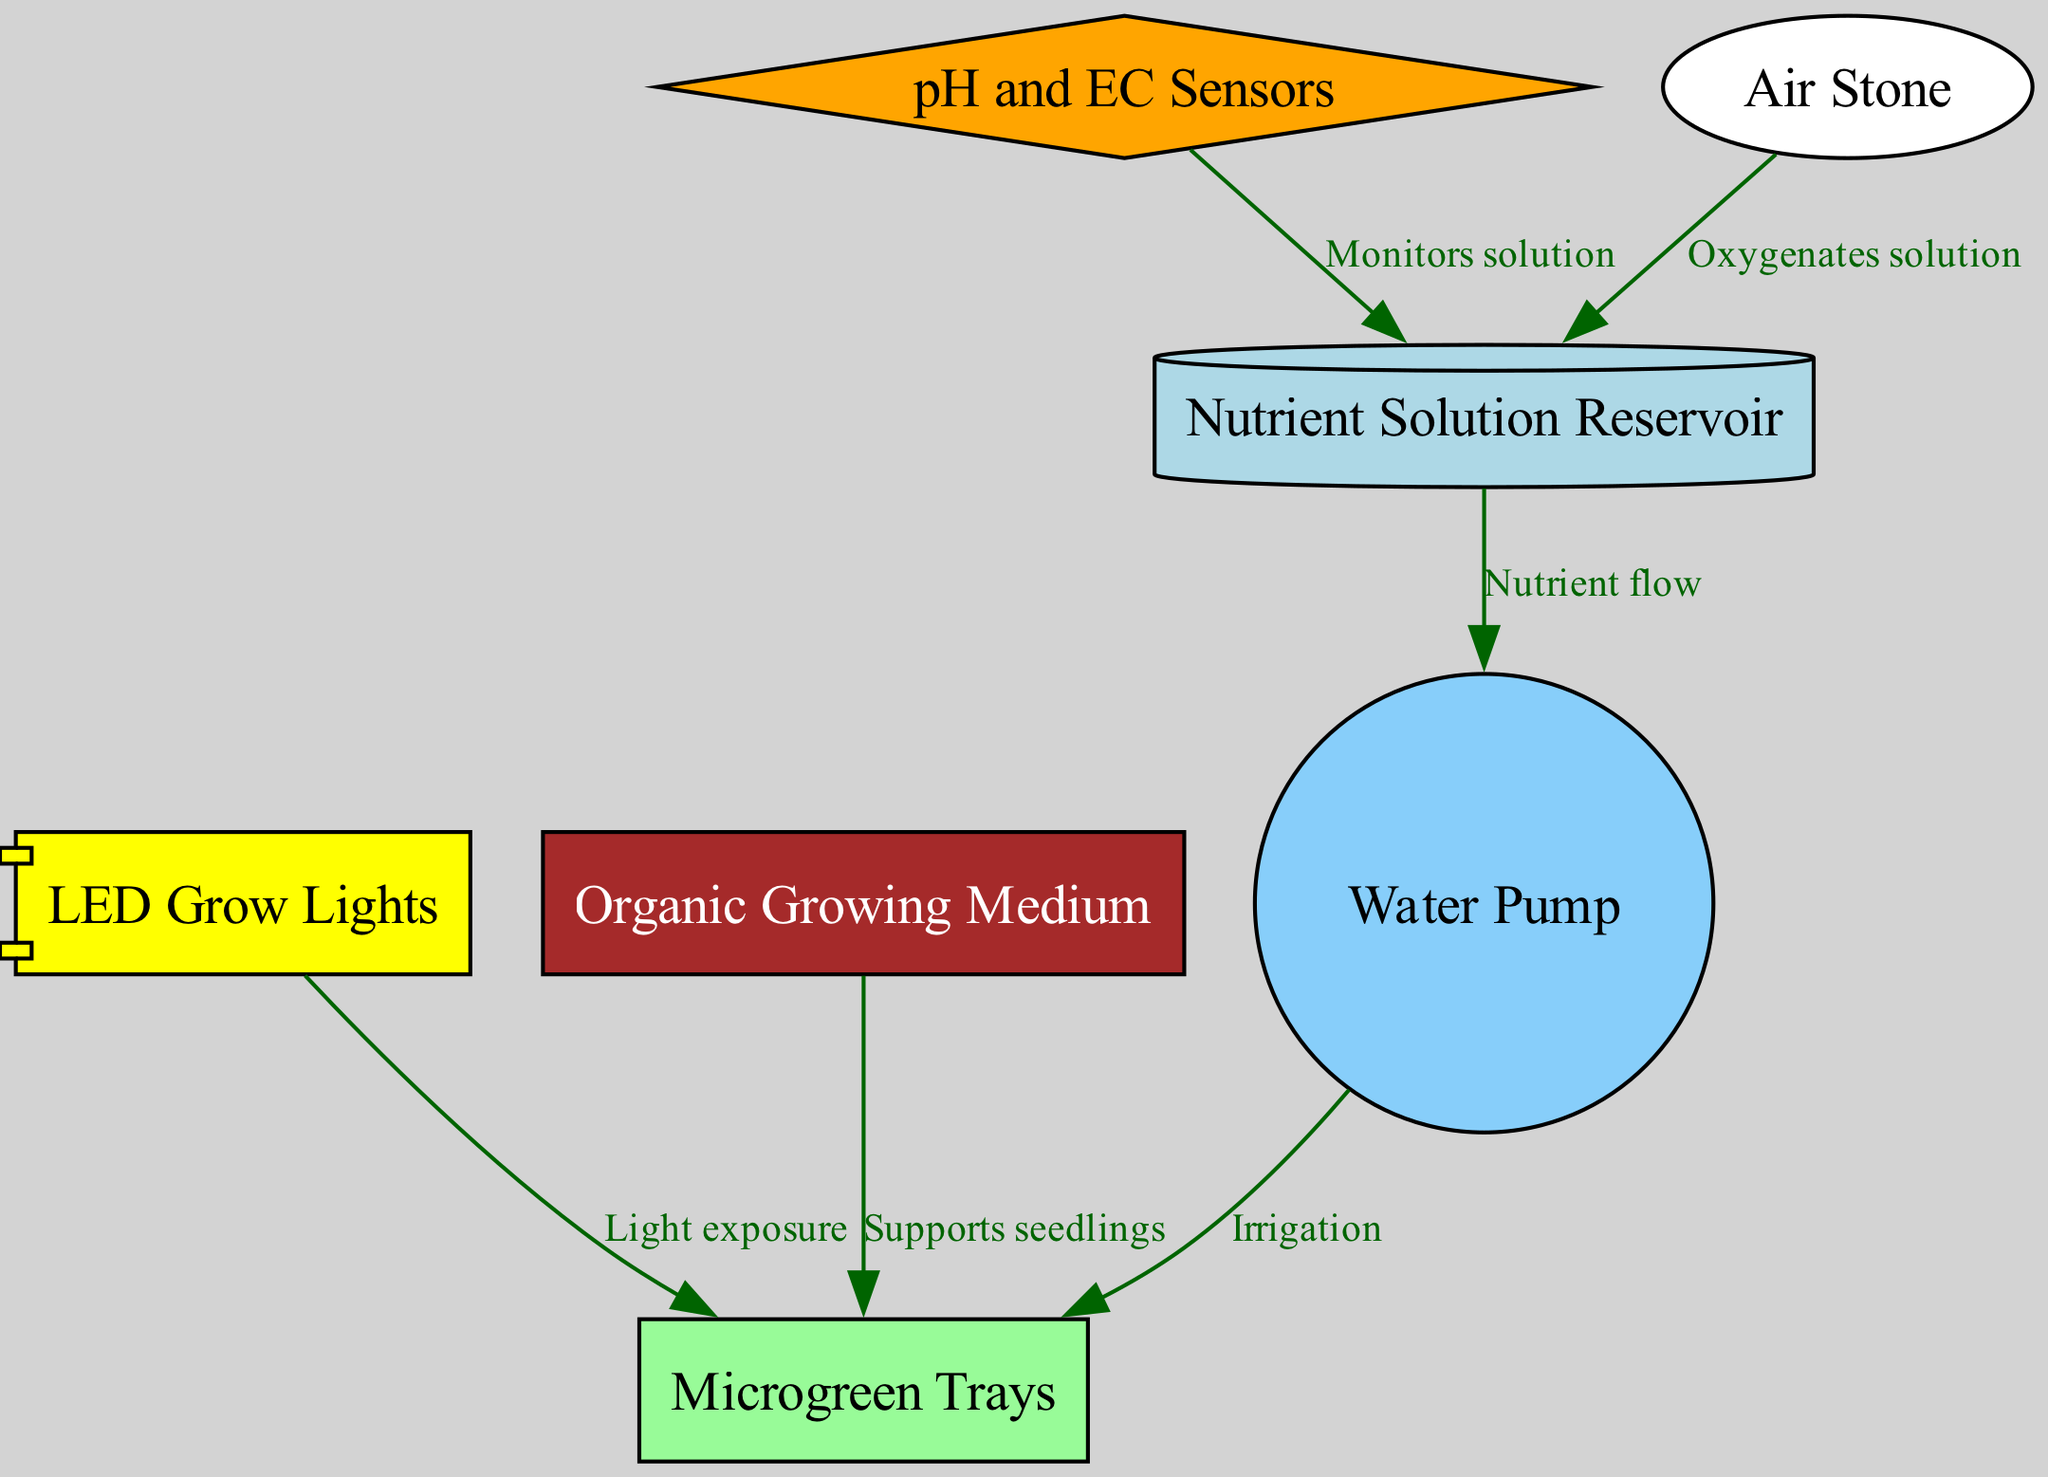What is the shape of the LED Grow Lights node? The LED Grow Lights node in the diagram is represented as a component shape, indicating its importance and functionality within the system.
Answer: component How many nodes are present in the diagram? The diagram contains seven nodes including LED Grow Lights, Nutrient Solution Reservoir, Microgreen Trays, Organic Growing Medium, Water Pump, pH and EC Sensors, and Air Stone.
Answer: seven What type of flow is indicated between the Nutrient Solution Reservoir and the Water Pump? The relationship shown in the diagram between the Nutrient Solution Reservoir and the Water Pump is labeled as "Nutrient flow," indicating that the nutrients are transported from the reservoir to the pump.
Answer: Nutrient flow Which node oxygenates the solution? The Air Stone node is responsible for oxygenating the solution, as indicated by the direct connection labeled "Oxygenates solution" to the Nutrient Solution Reservoir.
Answer: Air Stone What is the function of the pH and EC Sensors in relation to the Nutrient Solution Reservoir? The pH and EC Sensors monitor the solution in the Nutrient Solution Reservoir, allowing for adjustments to maintain optimal growth conditions as indicated by the edge labeled "Monitors solution."
Answer: Monitors solution How do the LED Grow Lights affect the Microgreen Trays? The LED Grow Lights provide light exposure to the Microgreen Trays, as indicated by the directional edge between them labeled "Light exposure," which is crucial for photosynthesis in the microgreens.
Answer: Light exposure Which nodes are directly connected to the Microgreen Trays? The Microgreen Trays are connected directly to the LED Grow Lights, Water Pump, Organic Growing Medium, and pH and EC Sensors, indicating their interdependent functionality within the hydroponic system.
Answer: LED Grow Lights, Water Pump, Organic Growing Medium, pH and EC Sensors What type of sensor technology is used in this hydroponic system? The diagram features pH and EC Sensors, which are essential for monitoring the acidity and electrical conductivity of the nutrient solution as part of the system's management.
Answer: pH and EC Sensors What role does the Water Pump play in the system? The Water Pump is responsible for irrigation by delivering the nutrient solution from the Nutrient Solution Reservoir to the Microgreen Trays, facilitating plant growth.
Answer: Irrigation 